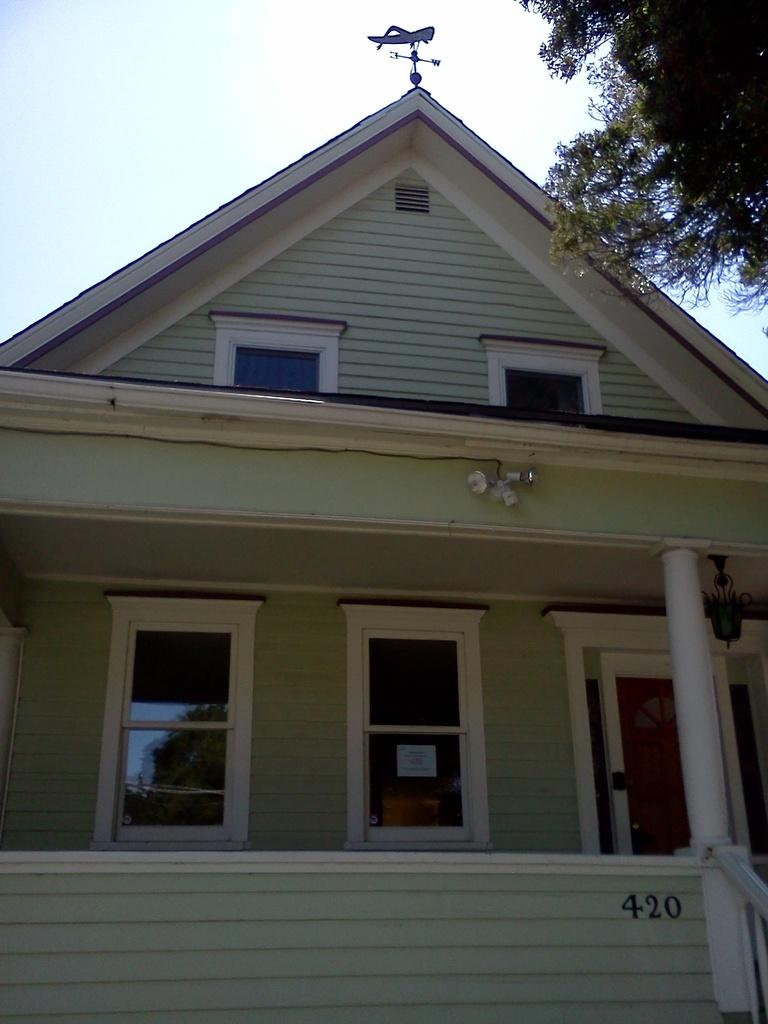What type of structure is in the picture? There is a house in the picture. What features can be seen on the house? The house has windows. What is located on the right side of the image? There are trees on the right side of the image. What is the condition of the sky in the picture? The sky is clear in the image. Is there any indication of payment being made in the image? There is no indication of payment being made in the image. Can you see the grandmother in the image? There is no grandmother present in the image. 